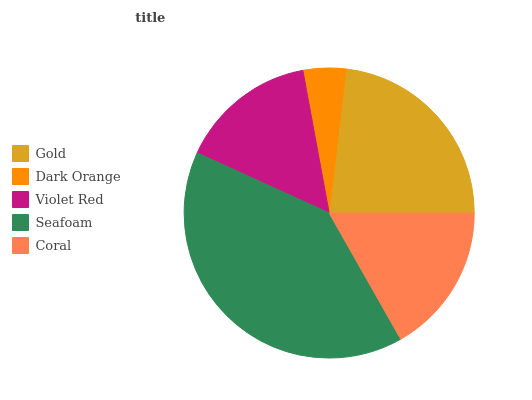Is Dark Orange the minimum?
Answer yes or no. Yes. Is Seafoam the maximum?
Answer yes or no. Yes. Is Violet Red the minimum?
Answer yes or no. No. Is Violet Red the maximum?
Answer yes or no. No. Is Violet Red greater than Dark Orange?
Answer yes or no. Yes. Is Dark Orange less than Violet Red?
Answer yes or no. Yes. Is Dark Orange greater than Violet Red?
Answer yes or no. No. Is Violet Red less than Dark Orange?
Answer yes or no. No. Is Coral the high median?
Answer yes or no. Yes. Is Coral the low median?
Answer yes or no. Yes. Is Violet Red the high median?
Answer yes or no. No. Is Gold the low median?
Answer yes or no. No. 